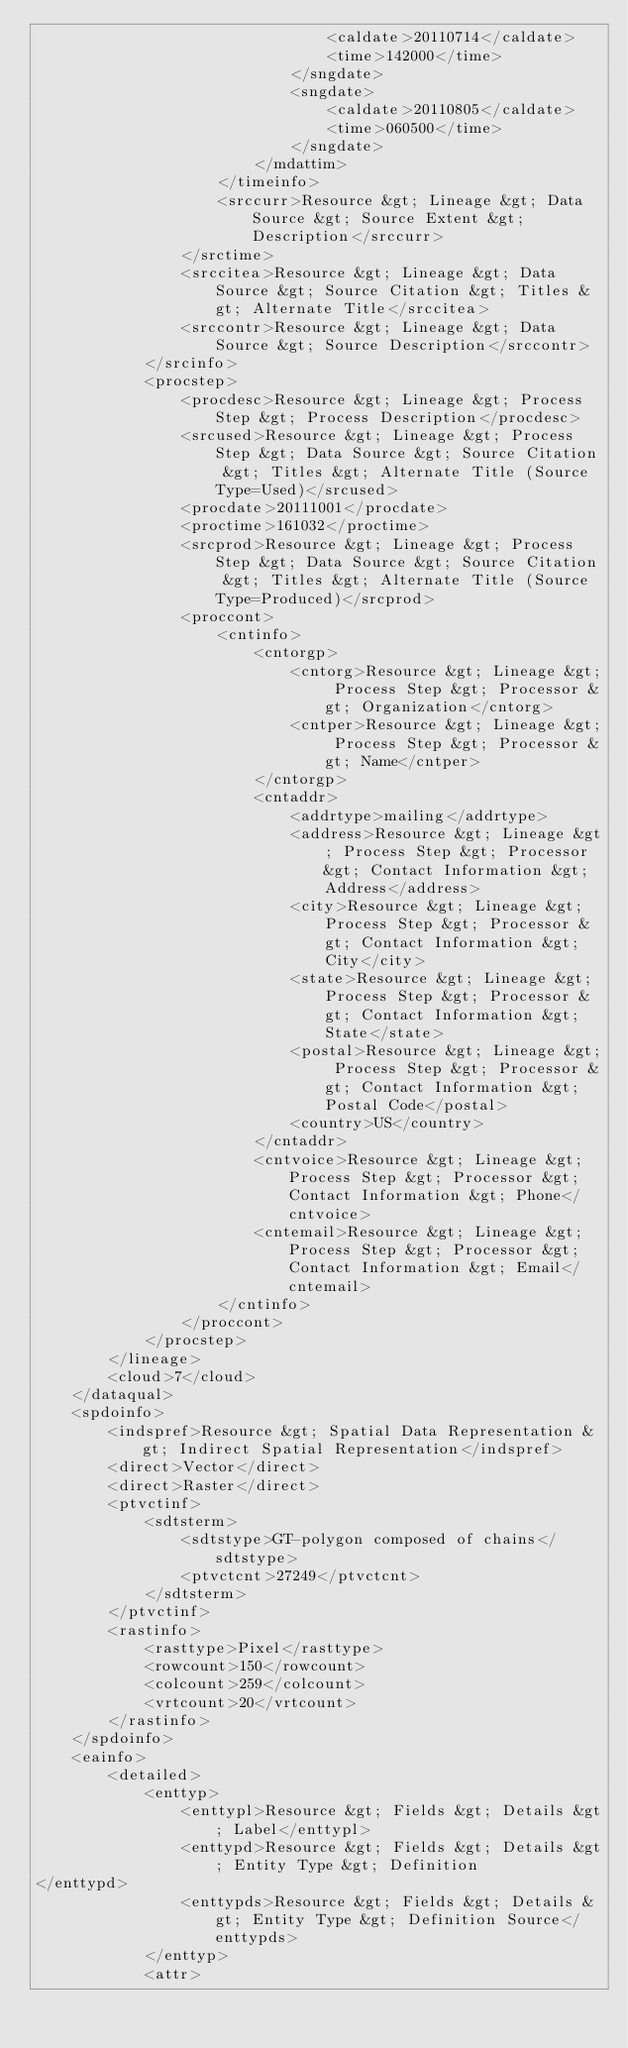Convert code to text. <code><loc_0><loc_0><loc_500><loc_500><_XML_>								<caldate>20110714</caldate>
								<time>142000</time>
							</sngdate>
							<sngdate>
								<caldate>20110805</caldate>
								<time>060500</time>
							</sngdate>
						</mdattim>
					</timeinfo>
					<srccurr>Resource &gt; Lineage &gt; Data Source &gt; Source Extent &gt; Description</srccurr>
				</srctime>
				<srccitea>Resource &gt; Lineage &gt; Data Source &gt; Source Citation &gt; Titles &gt; Alternate Title</srccitea>
				<srccontr>Resource &gt; Lineage &gt; Data Source &gt; Source Description</srccontr>
			</srcinfo>
			<procstep>
				<procdesc>Resource &gt; Lineage &gt; Process Step &gt; Process Description</procdesc>
				<srcused>Resource &gt; Lineage &gt; Process Step &gt; Data Source &gt; Source Citation &gt; Titles &gt; Alternate Title (Source Type=Used)</srcused>
				<procdate>20111001</procdate>
				<proctime>161032</proctime>
				<srcprod>Resource &gt; Lineage &gt; Process Step &gt; Data Source &gt; Source Citation &gt; Titles &gt; Alternate Title (Source Type=Produced)</srcprod>
				<proccont>
					<cntinfo>
						<cntorgp>
							<cntorg>Resource &gt; Lineage &gt; Process Step &gt; Processor &gt; Organization</cntorg>
							<cntper>Resource &gt; Lineage &gt; Process Step &gt; Processor &gt; Name</cntper>
						</cntorgp>
						<cntaddr>
							<addrtype>mailing</addrtype>
							<address>Resource &gt; Lineage &gt; Process Step &gt; Processor &gt; Contact Information &gt; Address</address>
							<city>Resource &gt; Lineage &gt; Process Step &gt; Processor &gt; Contact Information &gt; City</city>
							<state>Resource &gt; Lineage &gt; Process Step &gt; Processor &gt; Contact Information &gt; State</state>
							<postal>Resource &gt; Lineage &gt; Process Step &gt; Processor &gt; Contact Information &gt; Postal Code</postal>
							<country>US</country>
						</cntaddr>
						<cntvoice>Resource &gt; Lineage &gt; Process Step &gt; Processor &gt; Contact Information &gt; Phone</cntvoice>
						<cntemail>Resource &gt; Lineage &gt; Process Step &gt; Processor &gt; Contact Information &gt; Email</cntemail>
					</cntinfo>
				</proccont>
			</procstep>
		</lineage>
		<cloud>7</cloud>
	</dataqual>
	<spdoinfo>
		<indspref>Resource &gt; Spatial Data Representation &gt; Indirect Spatial Representation</indspref>
		<direct>Vector</direct>
		<direct>Raster</direct>
		<ptvctinf>
			<sdtsterm>
				<sdtstype>GT-polygon composed of chains</sdtstype>
				<ptvctcnt>27249</ptvctcnt>
			</sdtsterm>
		</ptvctinf>
		<rastinfo>
			<rasttype>Pixel</rasttype>
			<rowcount>150</rowcount>
			<colcount>259</colcount>
			<vrtcount>20</vrtcount>
		</rastinfo>
	</spdoinfo>
	<eainfo>
		<detailed>
			<enttyp>
				<enttypl>Resource &gt; Fields &gt; Details &gt; Label</enttypl>
				<enttypd>Resource &gt; Fields &gt; Details &gt; Entity Type &gt; Definition
</enttypd>
				<enttypds>Resource &gt; Fields &gt; Details &gt; Entity Type &gt; Definition Source</enttypds>
			</enttyp>
			<attr></code> 